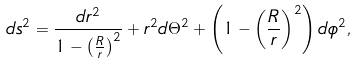Convert formula to latex. <formula><loc_0><loc_0><loc_500><loc_500>d s ^ { 2 } = \frac { d r ^ { 2 } } { 1 - \left ( \frac { R } { r } \right ) ^ { 2 } } + r ^ { 2 } d \Theta ^ { 2 } + \left ( 1 - \left ( \frac { R } { r } \right ) ^ { 2 } \right ) d \phi ^ { 2 } ,</formula> 